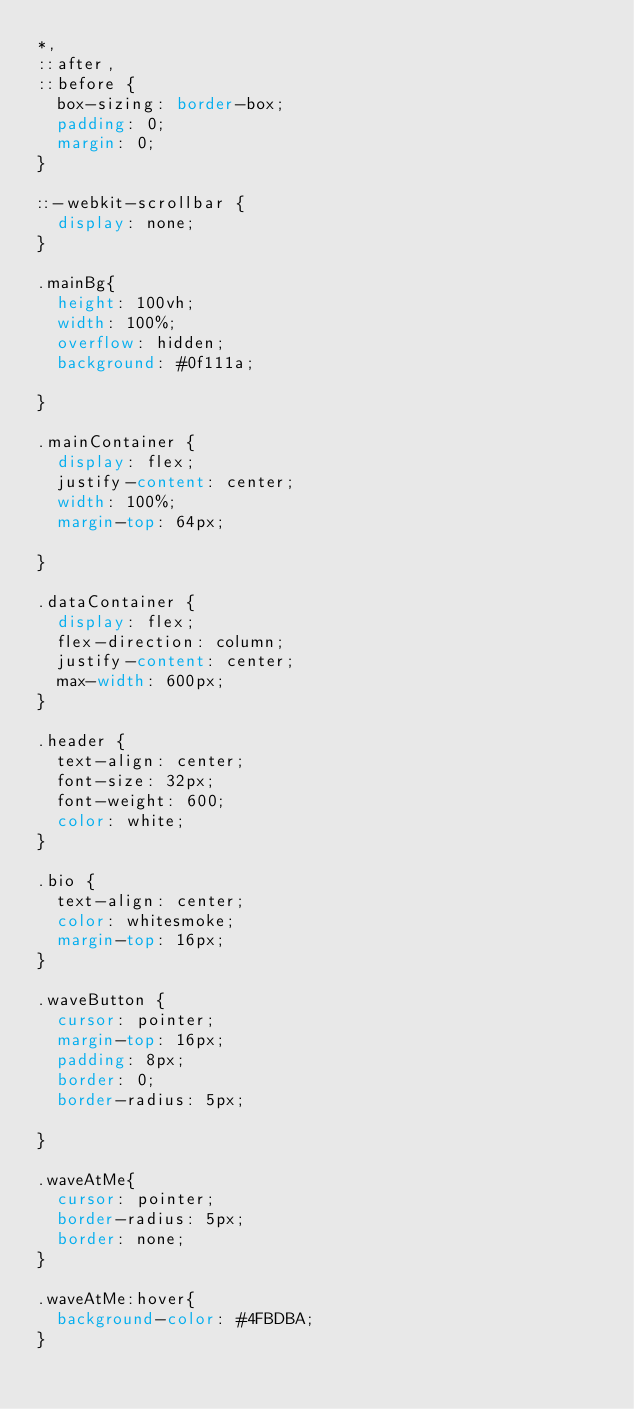Convert code to text. <code><loc_0><loc_0><loc_500><loc_500><_CSS_>*,
::after,
::before {
  box-sizing: border-box;
  padding: 0;
  margin: 0;
}

::-webkit-scrollbar {
  display: none;
}

.mainBg{
  height: 100vh;
  width: 100%;
  overflow: hidden;
  background: #0f111a;

}

.mainContainer {
  display: flex;
  justify-content: center;
  width: 100%;
  margin-top: 64px;
  
}

.dataContainer {
  display: flex;
  flex-direction: column;
  justify-content: center;
  max-width: 600px;
}

.header {
  text-align: center;
  font-size: 32px;
  font-weight: 600;
  color: white;
}

.bio {
  text-align: center;
  color: whitesmoke;
  margin-top: 16px;
}

.waveButton {
  cursor: pointer;
  margin-top: 16px;
  padding: 8px;
  border: 0;
  border-radius: 5px;
  
}

.waveAtMe{
  cursor: pointer;
  border-radius: 5px;
  border: none;
}

.waveAtMe:hover{
  background-color: #4FBDBA;
}</code> 